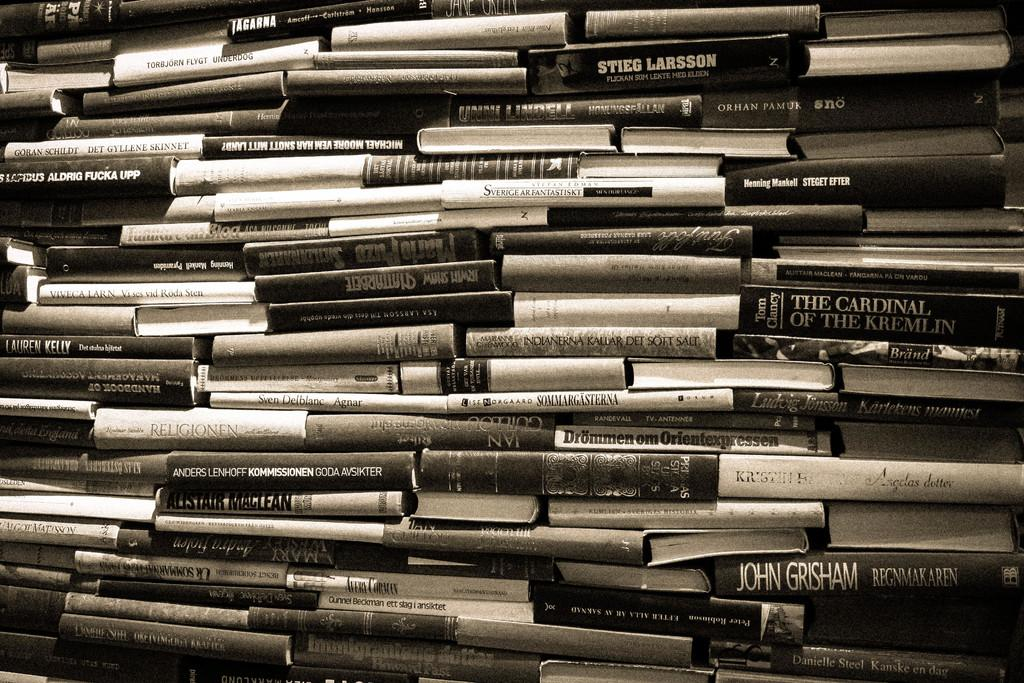<image>
Provide a brief description of the given image. A big stack of books includes The Cardinal of the Kremlin and a John Grisham novel. 